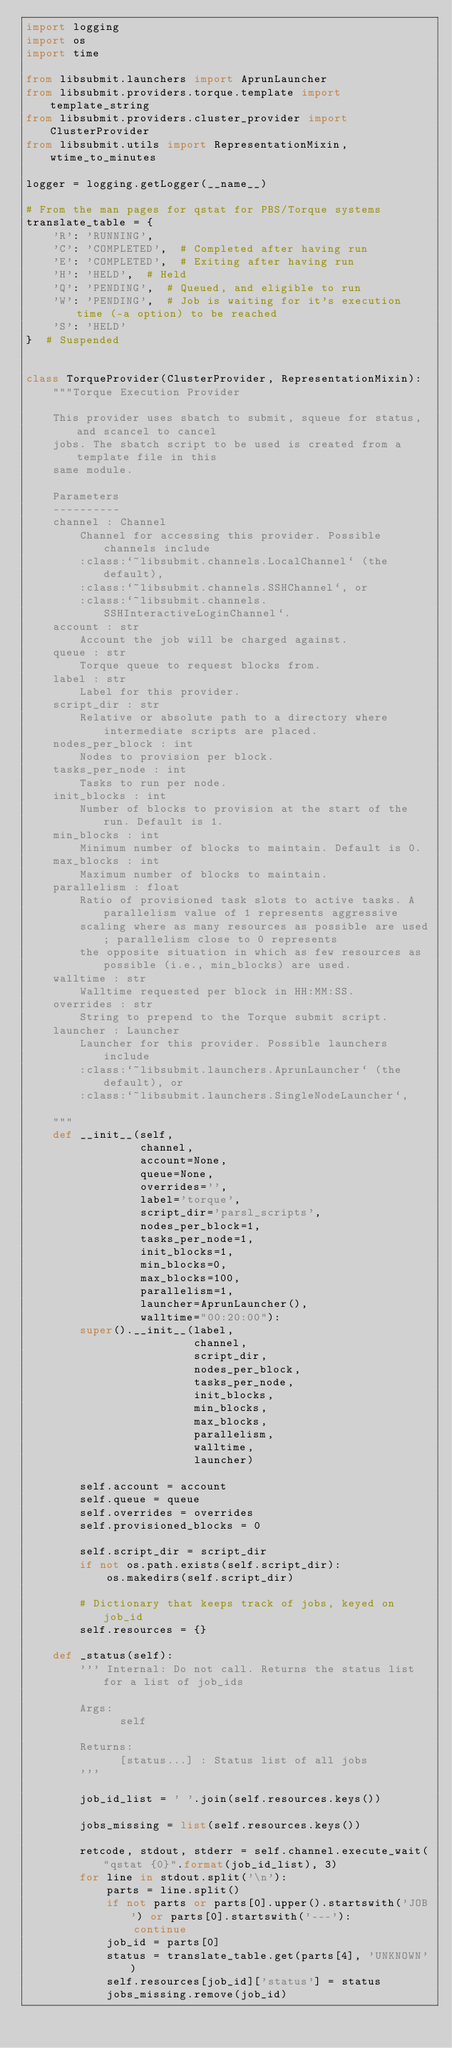<code> <loc_0><loc_0><loc_500><loc_500><_Python_>import logging
import os
import time

from libsubmit.launchers import AprunLauncher
from libsubmit.providers.torque.template import template_string
from libsubmit.providers.cluster_provider import ClusterProvider
from libsubmit.utils import RepresentationMixin, wtime_to_minutes

logger = logging.getLogger(__name__)

# From the man pages for qstat for PBS/Torque systems
translate_table = {
    'R': 'RUNNING',
    'C': 'COMPLETED',  # Completed after having run
    'E': 'COMPLETED',  # Exiting after having run
    'H': 'HELD',  # Held
    'Q': 'PENDING',  # Queued, and eligible to run
    'W': 'PENDING',  # Job is waiting for it's execution time (-a option) to be reached
    'S': 'HELD'
}  # Suspended


class TorqueProvider(ClusterProvider, RepresentationMixin):
    """Torque Execution Provider

    This provider uses sbatch to submit, squeue for status, and scancel to cancel
    jobs. The sbatch script to be used is created from a template file in this
    same module.

    Parameters
    ----------
    channel : Channel
        Channel for accessing this provider. Possible channels include
        :class:`~libsubmit.channels.LocalChannel` (the default),
        :class:`~libsubmit.channels.SSHChannel`, or
        :class:`~libsubmit.channels.SSHInteractiveLoginChannel`.
    account : str
        Account the job will be charged against.
    queue : str
        Torque queue to request blocks from.
    label : str
        Label for this provider.
    script_dir : str
        Relative or absolute path to a directory where intermediate scripts are placed.
    nodes_per_block : int
        Nodes to provision per block.
    tasks_per_node : int
        Tasks to run per node.
    init_blocks : int
        Number of blocks to provision at the start of the run. Default is 1.
    min_blocks : int
        Minimum number of blocks to maintain. Default is 0.
    max_blocks : int
        Maximum number of blocks to maintain.
    parallelism : float
        Ratio of provisioned task slots to active tasks. A parallelism value of 1 represents aggressive
        scaling where as many resources as possible are used; parallelism close to 0 represents
        the opposite situation in which as few resources as possible (i.e., min_blocks) are used.
    walltime : str
        Walltime requested per block in HH:MM:SS.
    overrides : str
        String to prepend to the Torque submit script.
    launcher : Launcher
        Launcher for this provider. Possible launchers include
        :class:`~libsubmit.launchers.AprunLauncher` (the default), or
        :class:`~libsubmit.launchers.SingleNodeLauncher`,

    """
    def __init__(self,
                 channel,
                 account=None,
                 queue=None,
                 overrides='',
                 label='torque',
                 script_dir='parsl_scripts',
                 nodes_per_block=1,
                 tasks_per_node=1,
                 init_blocks=1,
                 min_blocks=0,
                 max_blocks=100,
                 parallelism=1,
                 launcher=AprunLauncher(),
                 walltime="00:20:00"):
        super().__init__(label,
                         channel,
                         script_dir,
                         nodes_per_block,
                         tasks_per_node,
                         init_blocks,
                         min_blocks,
                         max_blocks,
                         parallelism,
                         walltime,
                         launcher)

        self.account = account
        self.queue = queue
        self.overrides = overrides
        self.provisioned_blocks = 0

        self.script_dir = script_dir
        if not os.path.exists(self.script_dir):
            os.makedirs(self.script_dir)

        # Dictionary that keeps track of jobs, keyed on job_id
        self.resources = {}

    def _status(self):
        ''' Internal: Do not call. Returns the status list for a list of job_ids

        Args:
              self

        Returns:
              [status...] : Status list of all jobs
        '''

        job_id_list = ' '.join(self.resources.keys())

        jobs_missing = list(self.resources.keys())

        retcode, stdout, stderr = self.channel.execute_wait("qstat {0}".format(job_id_list), 3)
        for line in stdout.split('\n'):
            parts = line.split()
            if not parts or parts[0].upper().startswith('JOB') or parts[0].startswith('---'):
                continue
            job_id = parts[0]
            status = translate_table.get(parts[4], 'UNKNOWN')
            self.resources[job_id]['status'] = status
            jobs_missing.remove(job_id)
</code> 